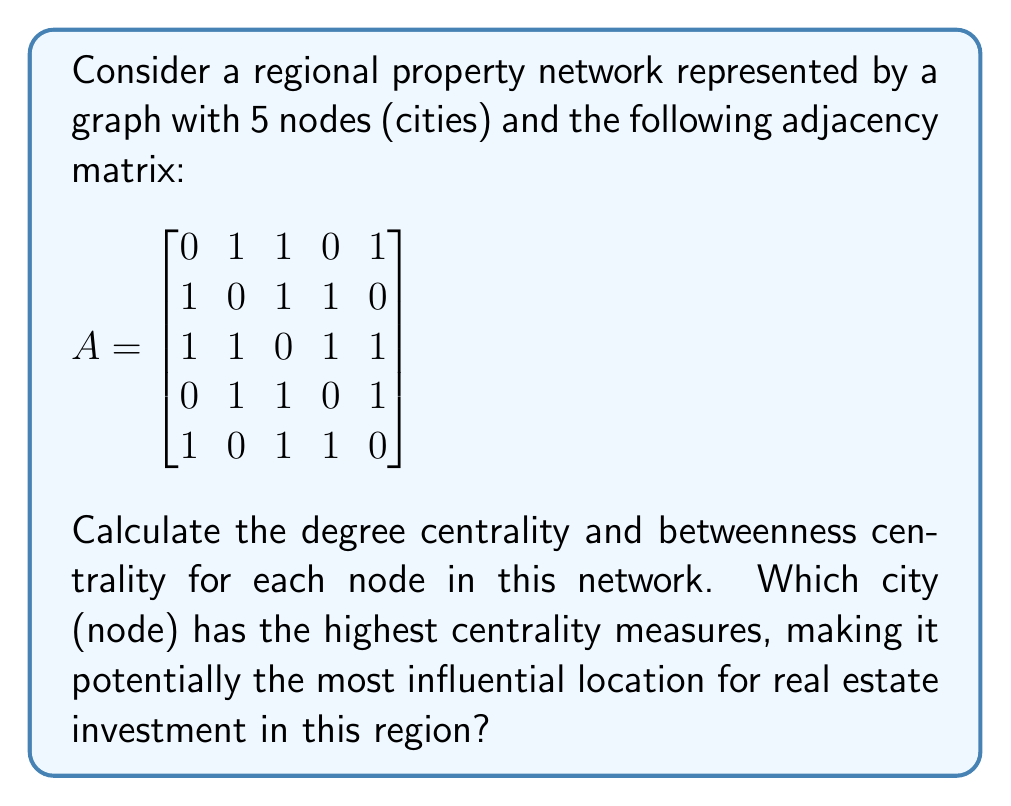Help me with this question. To solve this problem, we need to calculate two centrality measures for each node: degree centrality and betweenness centrality.

1. Degree Centrality:
Degree centrality is simply the number of connections a node has. For an undirected graph, it's the sum of the row (or column) in the adjacency matrix.

Node 1: $1 + 1 + 0 + 1 = 3$
Node 2: $1 + 1 + 1 + 0 = 3$
Node 3: $1 + 1 + 1 + 1 = 4$
Node 4: $0 + 1 + 1 + 1 = 3$
Node 5: $1 + 0 + 1 + 1 = 3$

2. Betweenness Centrality:
Betweenness centrality measures how often a node appears on the shortest paths between other nodes. To calculate this:

a) First, find all shortest paths between all pairs of nodes.
b) For each node, count how many of these shortest paths pass through it.
c) Normalize the count by dividing by the total number of shortest paths.

Let's calculate for each node:

Node 1: Appears in 0 shortest paths
Node 2: Appears in 1 shortest path (4-2-1)
Node 3: Appears in 4 shortest paths (1-3-4, 1-3-5, 2-3-5, 4-3-5)
Node 4: Appears in 1 shortest path (1-4-5)
Node 5: Appears in 0 shortest paths

Total number of shortest paths = 10

Normalized betweenness centrality:
Node 1: 0/10 = 0
Node 2: 1/10 = 0.1
Node 3: 4/10 = 0.4
Node 4: 1/10 = 0.1
Node 5: 0/10 = 0

Combining both measures:
Node 1: Degree = 3, Betweenness = 0
Node 2: Degree = 3, Betweenness = 0.1
Node 3: Degree = 4, Betweenness = 0.4
Node 4: Degree = 3, Betweenness = 0.1
Node 5: Degree = 3, Betweenness = 0

Node 3 has the highest centrality measures in both categories, making it potentially the most influential location for real estate investment in this region.
Answer: Node 3 (city 3) has the highest centrality measures with a degree centrality of 4 and a betweenness centrality of 0.4, making it potentially the most influential location for real estate investment in this regional property network. 